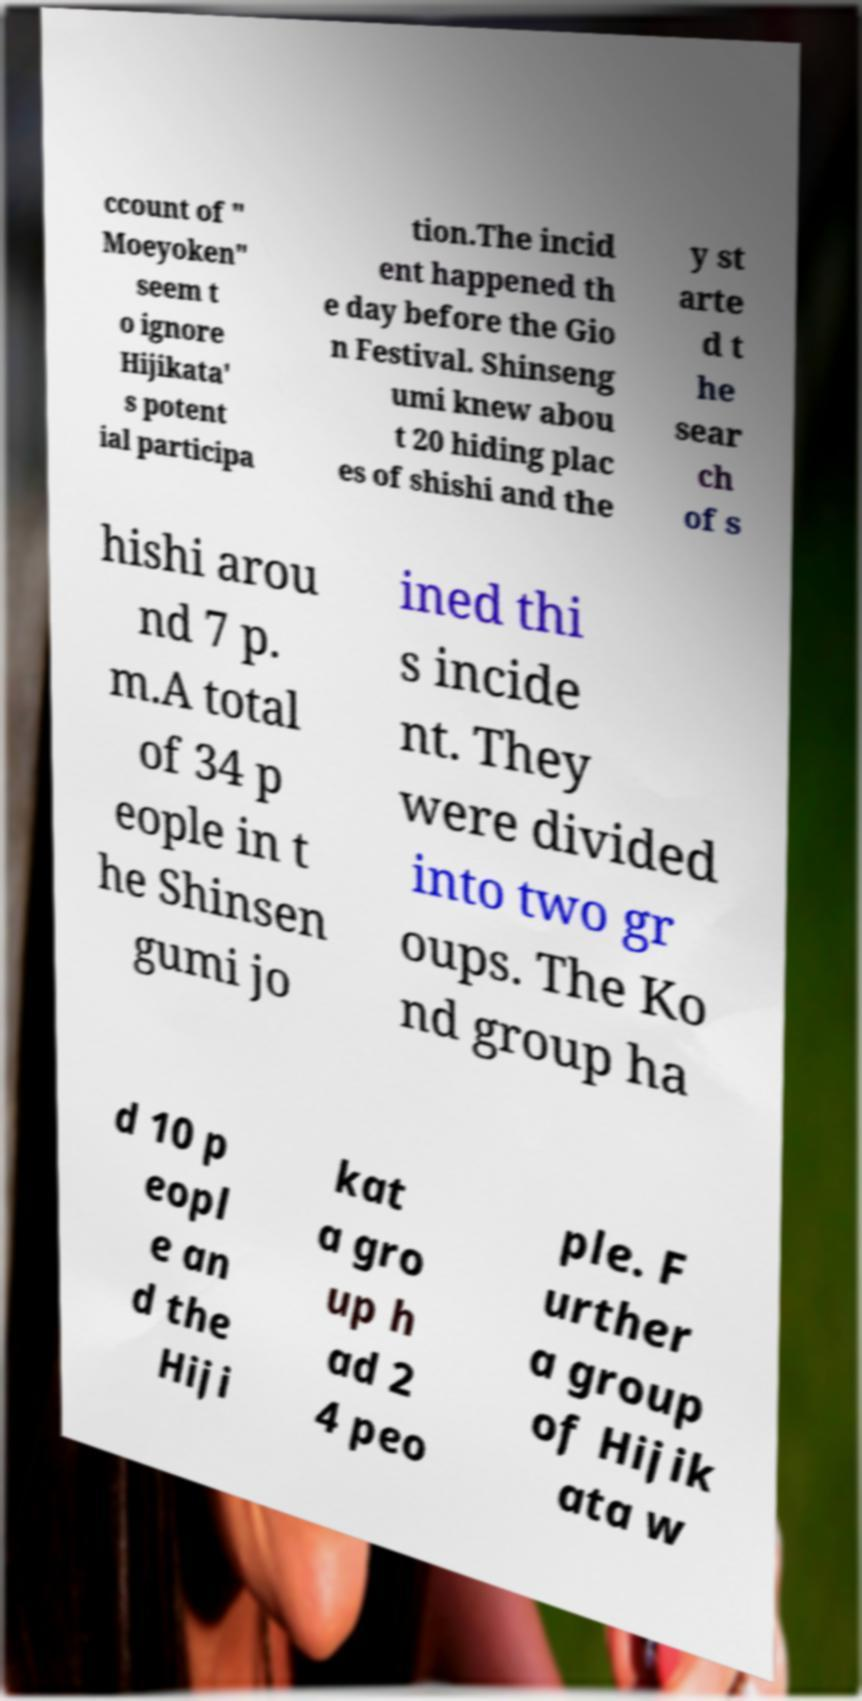For documentation purposes, I need the text within this image transcribed. Could you provide that? ccount of " Moeyoken" seem t o ignore Hijikata' s potent ial participa tion.The incid ent happened th e day before the Gio n Festival. Shinseng umi knew abou t 20 hiding plac es of shishi and the y st arte d t he sear ch of s hishi arou nd 7 p. m.A total of 34 p eople in t he Shinsen gumi jo ined thi s incide nt. They were divided into two gr oups. The Ko nd group ha d 10 p eopl e an d the Hiji kat a gro up h ad 2 4 peo ple. F urther a group of Hijik ata w 